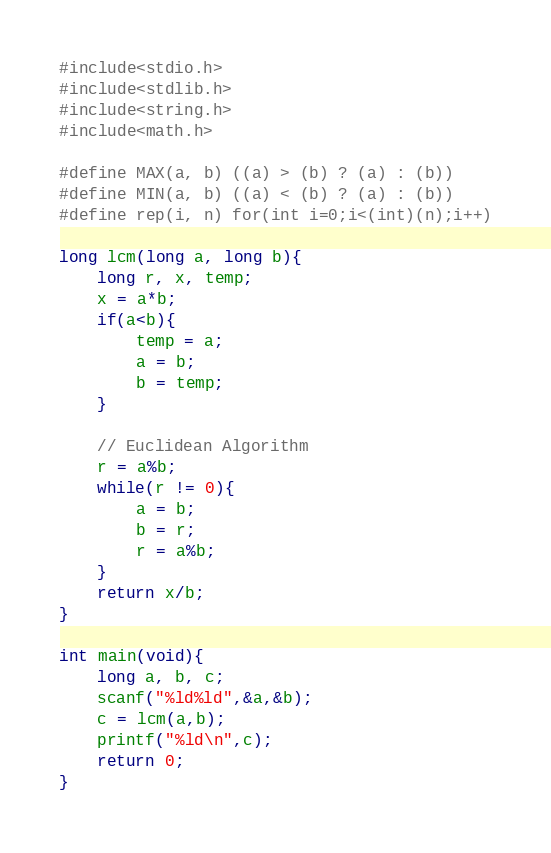<code> <loc_0><loc_0><loc_500><loc_500><_C_>#include<stdio.h>
#include<stdlib.h>
#include<string.h>
#include<math.h>

#define MAX(a, b) ((a) > (b) ? (a) : (b))
#define MIN(a, b) ((a) < (b) ? (a) : (b))
#define rep(i, n) for(int i=0;i<(int)(n);i++)

long lcm(long a, long b){
    long r, x, temp;
    x = a*b;
    if(a<b){
        temp = a;
        a = b;
        b = temp;
    }
    
    // Euclidean Algorithm 
    r = a%b;
    while(r != 0){
        a = b;
        b = r;
        r = a%b;
    }
    return x/b;
}

int main(void){
    long a, b, c;
    scanf("%ld%ld",&a,&b);
    c = lcm(a,b);
    printf("%ld\n",c);
    return 0; 
}
</code> 